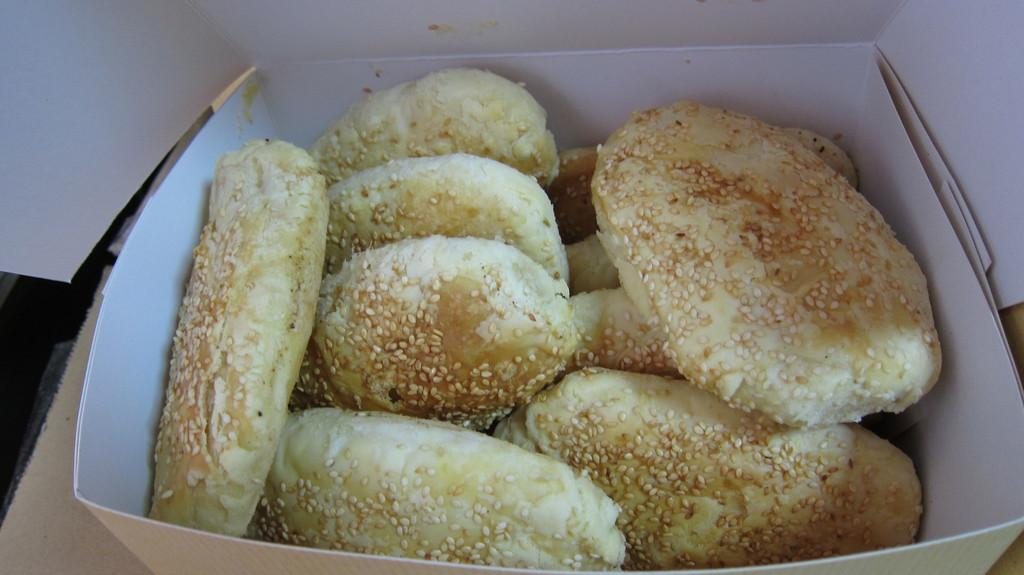What type of food is contained in the box in the image? There are snacks in a box in the image. Where is the box of snacks located? The box of snacks is on a table at the bottom of the image. What type of spade is being used to dig in the image? There is no spade present in the image; it only features a box of snacks on a table. 